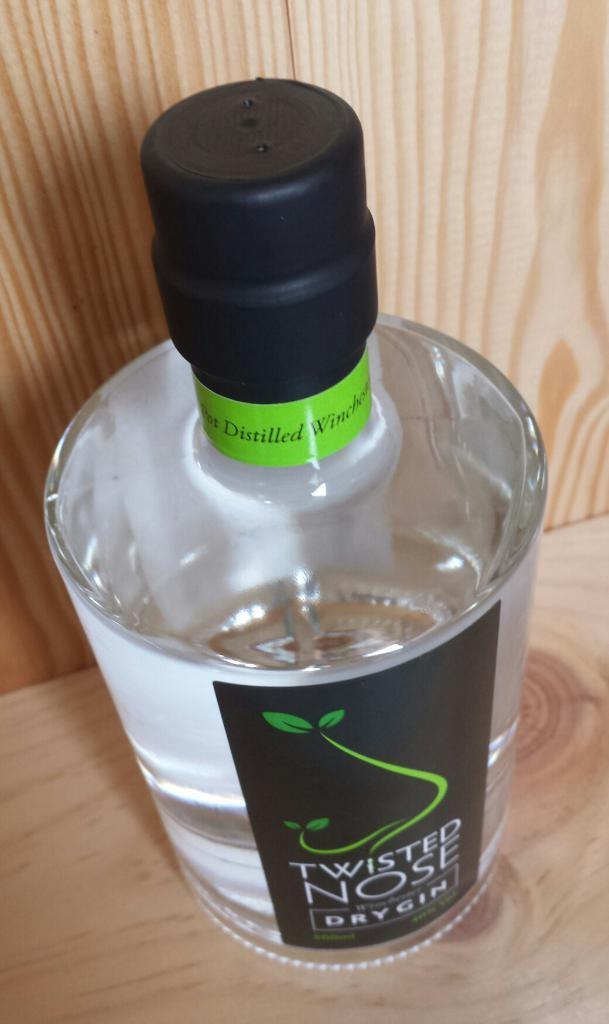<image>
Offer a succinct explanation of the picture presented. A large bottle of distilled Twisted Nose dry gin 